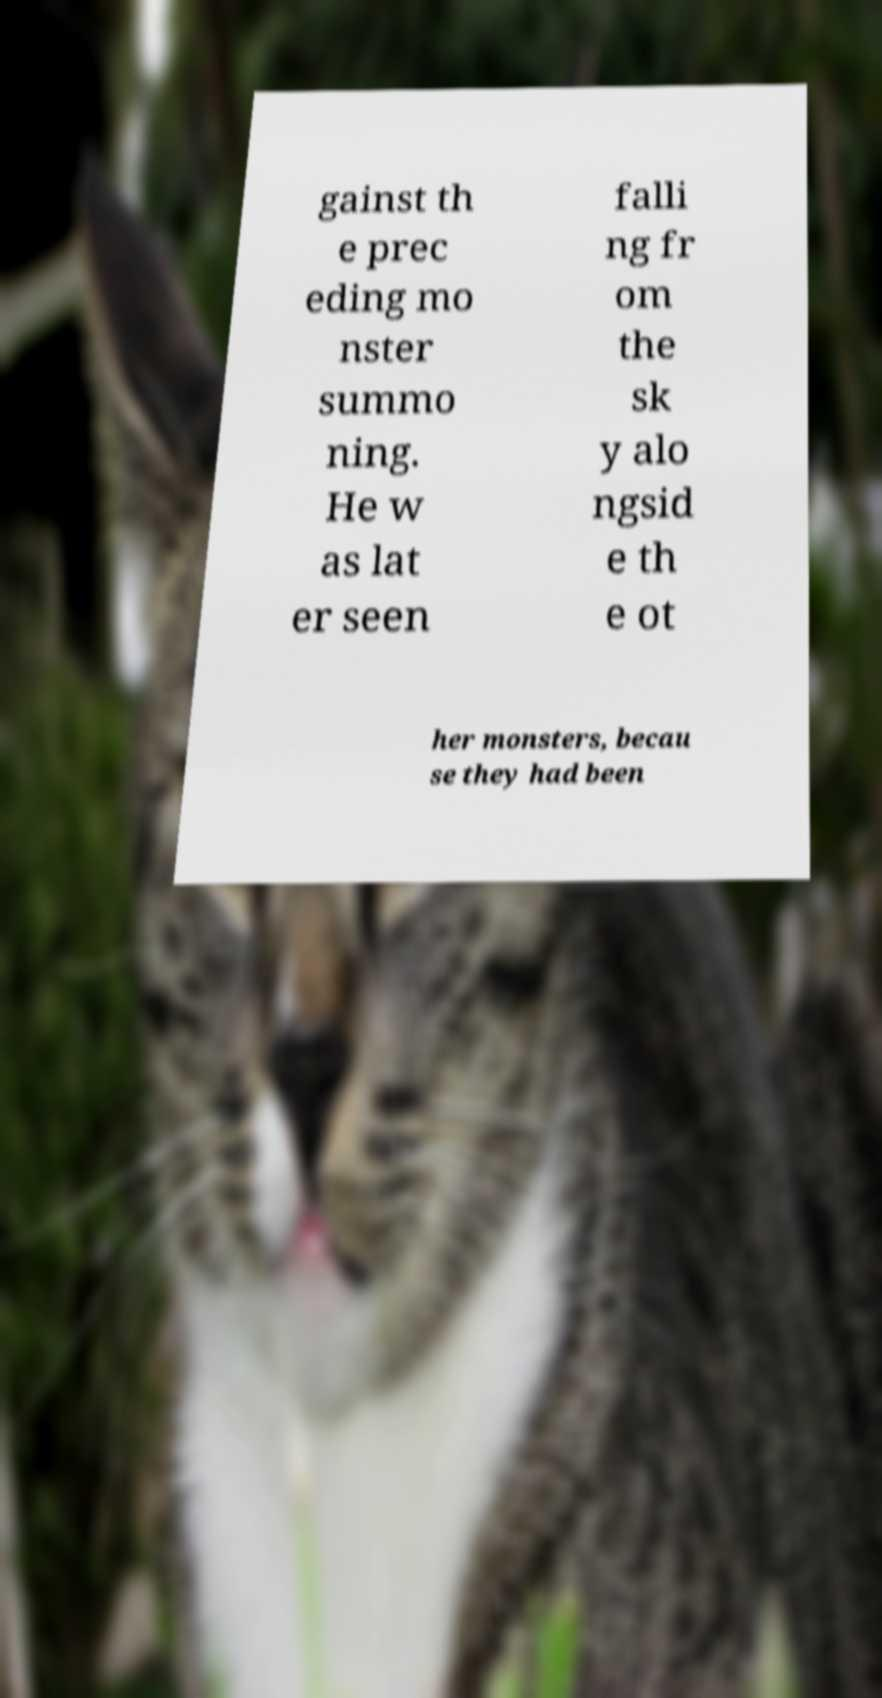What messages or text are displayed in this image? I need them in a readable, typed format. gainst th e prec eding mo nster summo ning. He w as lat er seen falli ng fr om the sk y alo ngsid e th e ot her monsters, becau se they had been 